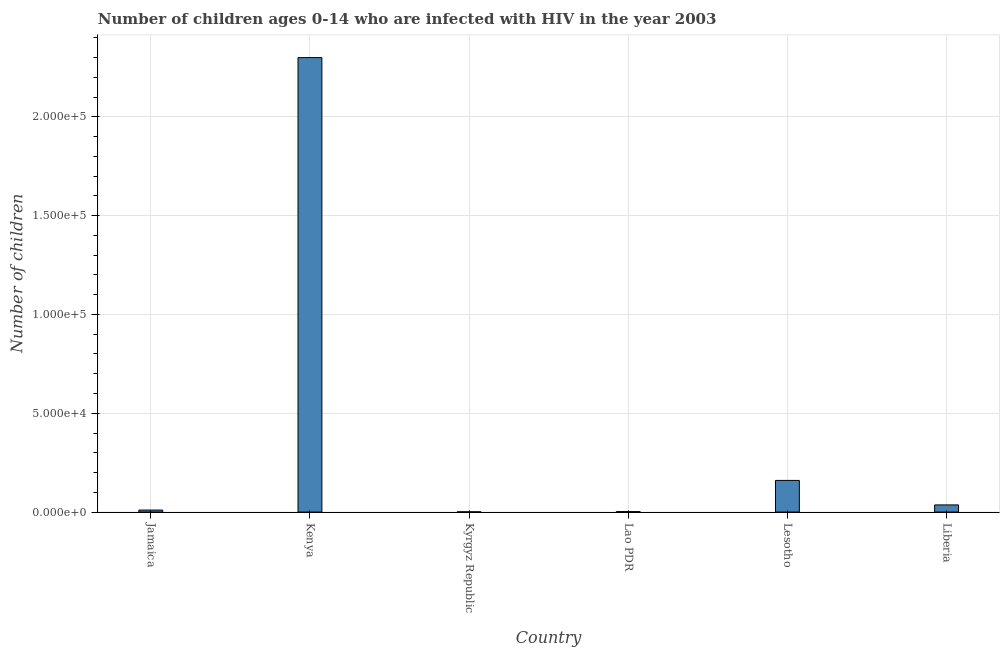Does the graph contain any zero values?
Offer a very short reply. No. Does the graph contain grids?
Keep it short and to the point. Yes. What is the title of the graph?
Offer a very short reply. Number of children ages 0-14 who are infected with HIV in the year 2003. What is the label or title of the Y-axis?
Your response must be concise. Number of children. Across all countries, what is the maximum number of children living with hiv?
Your answer should be compact. 2.30e+05. Across all countries, what is the minimum number of children living with hiv?
Make the answer very short. 100. In which country was the number of children living with hiv maximum?
Your answer should be very brief. Kenya. In which country was the number of children living with hiv minimum?
Provide a short and direct response. Kyrgyz Republic. What is the sum of the number of children living with hiv?
Offer a terse response. 2.51e+05. What is the difference between the number of children living with hiv in Kyrgyz Republic and Lesotho?
Provide a succinct answer. -1.59e+04. What is the average number of children living with hiv per country?
Your response must be concise. 4.18e+04. What is the median number of children living with hiv?
Offer a very short reply. 2300. What is the ratio of the number of children living with hiv in Jamaica to that in Liberia?
Provide a succinct answer. 0.28. What is the difference between the highest and the second highest number of children living with hiv?
Ensure brevity in your answer.  2.14e+05. Is the sum of the number of children living with hiv in Lao PDR and Liberia greater than the maximum number of children living with hiv across all countries?
Make the answer very short. No. What is the difference between the highest and the lowest number of children living with hiv?
Provide a short and direct response. 2.30e+05. In how many countries, is the number of children living with hiv greater than the average number of children living with hiv taken over all countries?
Provide a succinct answer. 1. Are all the bars in the graph horizontal?
Your answer should be compact. No. How many countries are there in the graph?
Provide a succinct answer. 6. What is the Number of children of Jamaica?
Offer a very short reply. 1000. What is the Number of children of Lao PDR?
Keep it short and to the point. 200. What is the Number of children of Lesotho?
Your answer should be compact. 1.60e+04. What is the Number of children of Liberia?
Keep it short and to the point. 3600. What is the difference between the Number of children in Jamaica and Kenya?
Make the answer very short. -2.29e+05. What is the difference between the Number of children in Jamaica and Kyrgyz Republic?
Provide a succinct answer. 900. What is the difference between the Number of children in Jamaica and Lao PDR?
Give a very brief answer. 800. What is the difference between the Number of children in Jamaica and Lesotho?
Your answer should be very brief. -1.50e+04. What is the difference between the Number of children in Jamaica and Liberia?
Your answer should be very brief. -2600. What is the difference between the Number of children in Kenya and Kyrgyz Republic?
Provide a succinct answer. 2.30e+05. What is the difference between the Number of children in Kenya and Lao PDR?
Ensure brevity in your answer.  2.30e+05. What is the difference between the Number of children in Kenya and Lesotho?
Give a very brief answer. 2.14e+05. What is the difference between the Number of children in Kenya and Liberia?
Your response must be concise. 2.26e+05. What is the difference between the Number of children in Kyrgyz Republic and Lao PDR?
Keep it short and to the point. -100. What is the difference between the Number of children in Kyrgyz Republic and Lesotho?
Make the answer very short. -1.59e+04. What is the difference between the Number of children in Kyrgyz Republic and Liberia?
Offer a terse response. -3500. What is the difference between the Number of children in Lao PDR and Lesotho?
Provide a succinct answer. -1.58e+04. What is the difference between the Number of children in Lao PDR and Liberia?
Provide a short and direct response. -3400. What is the difference between the Number of children in Lesotho and Liberia?
Offer a terse response. 1.24e+04. What is the ratio of the Number of children in Jamaica to that in Kenya?
Provide a short and direct response. 0. What is the ratio of the Number of children in Jamaica to that in Kyrgyz Republic?
Keep it short and to the point. 10. What is the ratio of the Number of children in Jamaica to that in Lesotho?
Give a very brief answer. 0.06. What is the ratio of the Number of children in Jamaica to that in Liberia?
Keep it short and to the point. 0.28. What is the ratio of the Number of children in Kenya to that in Kyrgyz Republic?
Your answer should be compact. 2300. What is the ratio of the Number of children in Kenya to that in Lao PDR?
Your response must be concise. 1150. What is the ratio of the Number of children in Kenya to that in Lesotho?
Make the answer very short. 14.38. What is the ratio of the Number of children in Kenya to that in Liberia?
Your response must be concise. 63.89. What is the ratio of the Number of children in Kyrgyz Republic to that in Lesotho?
Ensure brevity in your answer.  0.01. What is the ratio of the Number of children in Kyrgyz Republic to that in Liberia?
Your answer should be very brief. 0.03. What is the ratio of the Number of children in Lao PDR to that in Lesotho?
Your answer should be compact. 0.01. What is the ratio of the Number of children in Lao PDR to that in Liberia?
Your response must be concise. 0.06. What is the ratio of the Number of children in Lesotho to that in Liberia?
Your response must be concise. 4.44. 